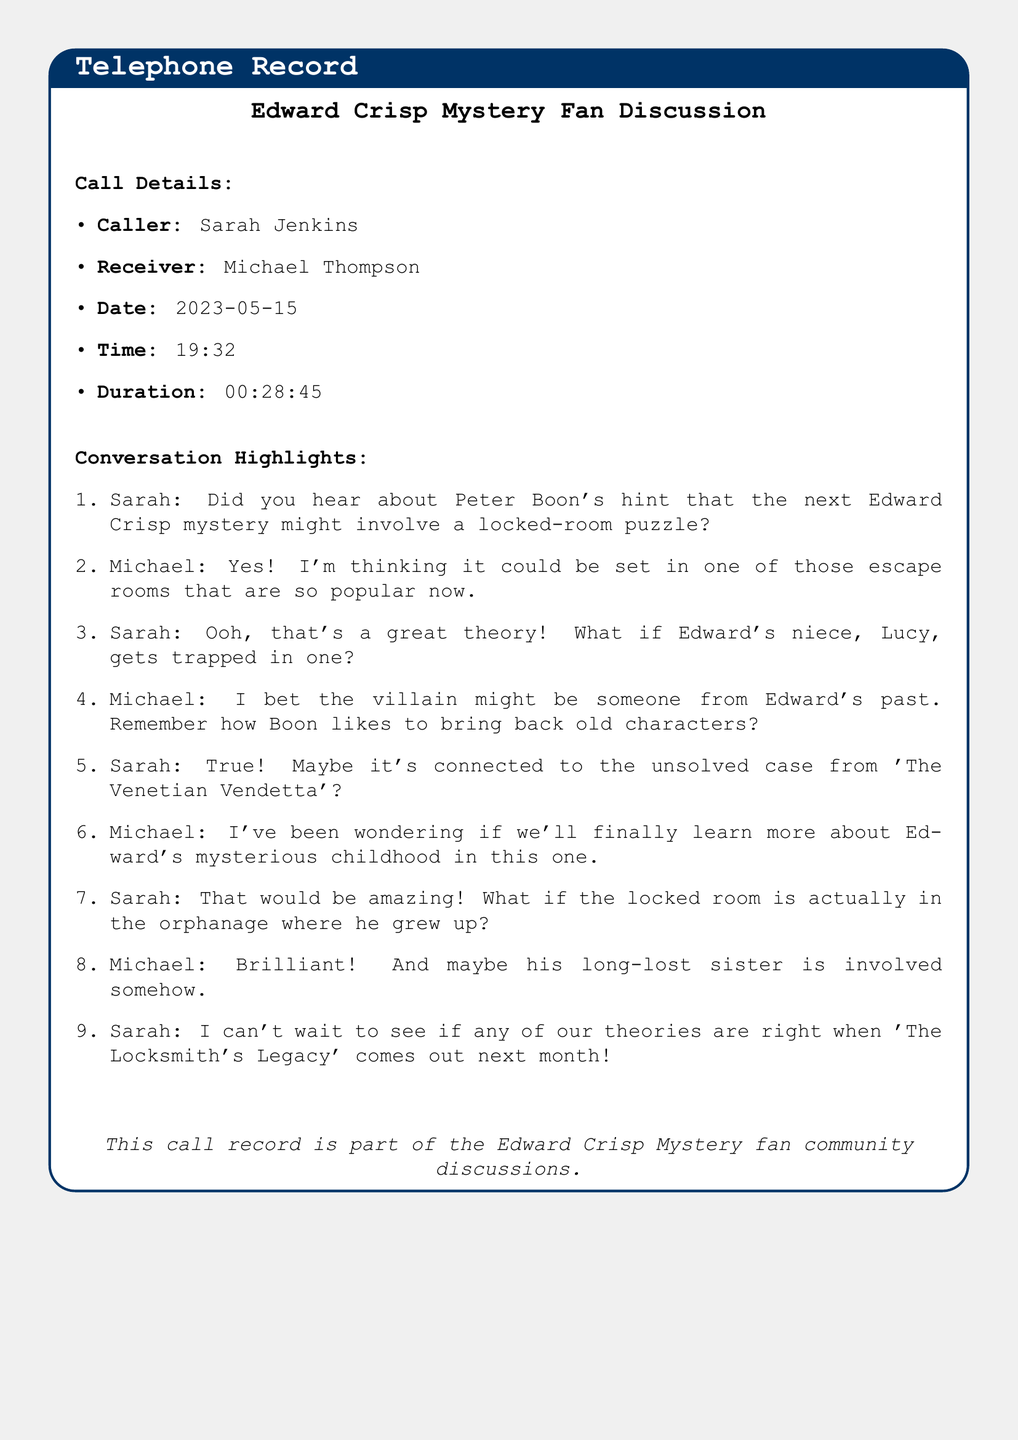What is the name of the caller? The caller of the conversation is identified as Sarah Jenkins.
Answer: Sarah Jenkins Who is the receiver of the call? The document specifies that the conversation was with Michael Thompson as the receiver.
Answer: Michael Thompson What date did the call take place? The date of the call is recorded as May 15, 2023.
Answer: 2023-05-15 What is the duration of the call? The length of the call is stated to be 28 minutes and 45 seconds.
Answer: 00:28:45 What plot element does Sarah mention in the beginning? Sarah mentions that Peter Boon's hint involves a locked-room puzzle.
Answer: locked-room puzzle What location does Michael suggest for the next mystery's setting? Michael proposes that the setting could be in one of the popular escape rooms.
Answer: escape rooms What character's past does Michael speculate the villain may be linked to? Michael speculates the villain might be someone from Edward's past.
Answer: Edward's past Which unsolved case does Sarah think might be connected to the new mystery? Sarah suggests a connection to the unsolved case from 'The Venetian Vendetta'.
Answer: The Venetian Vendetta What familial relationship is theorized to be involved in the new plot? Michael theorizes that Edward's long-lost sister could be involved in the new plot.
Answer: long-lost sister What is the title of the upcoming Edward Crisp mystery? The upcoming mystery is titled 'The Locksmith's Legacy'.
Answer: The Locksmith's Legacy 